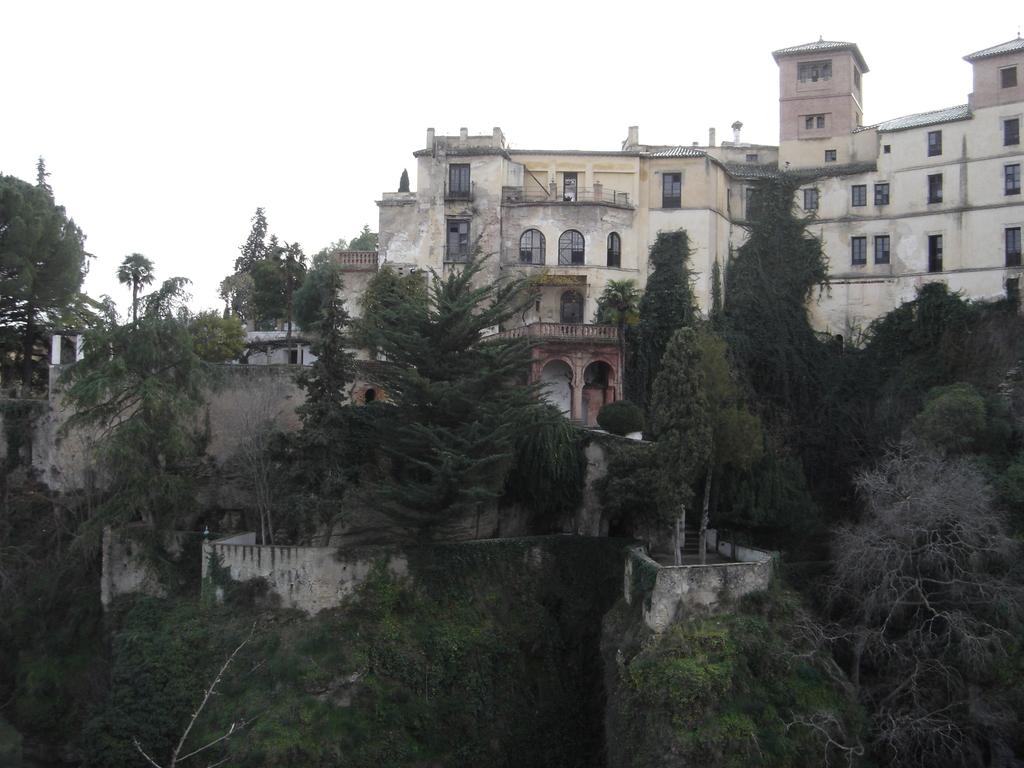What type of natural elements can be seen in the image? There are trees in the image. What type of man-made structures are present in the image? There are buildings in the image. What feature can be seen on the buildings? There are windows in the image. What is visible in the background of the image? The sky is visible in the background of the image. What type of liquid is being poured from the milk carton in the image? There is no milk carton or liquid present in the image. 